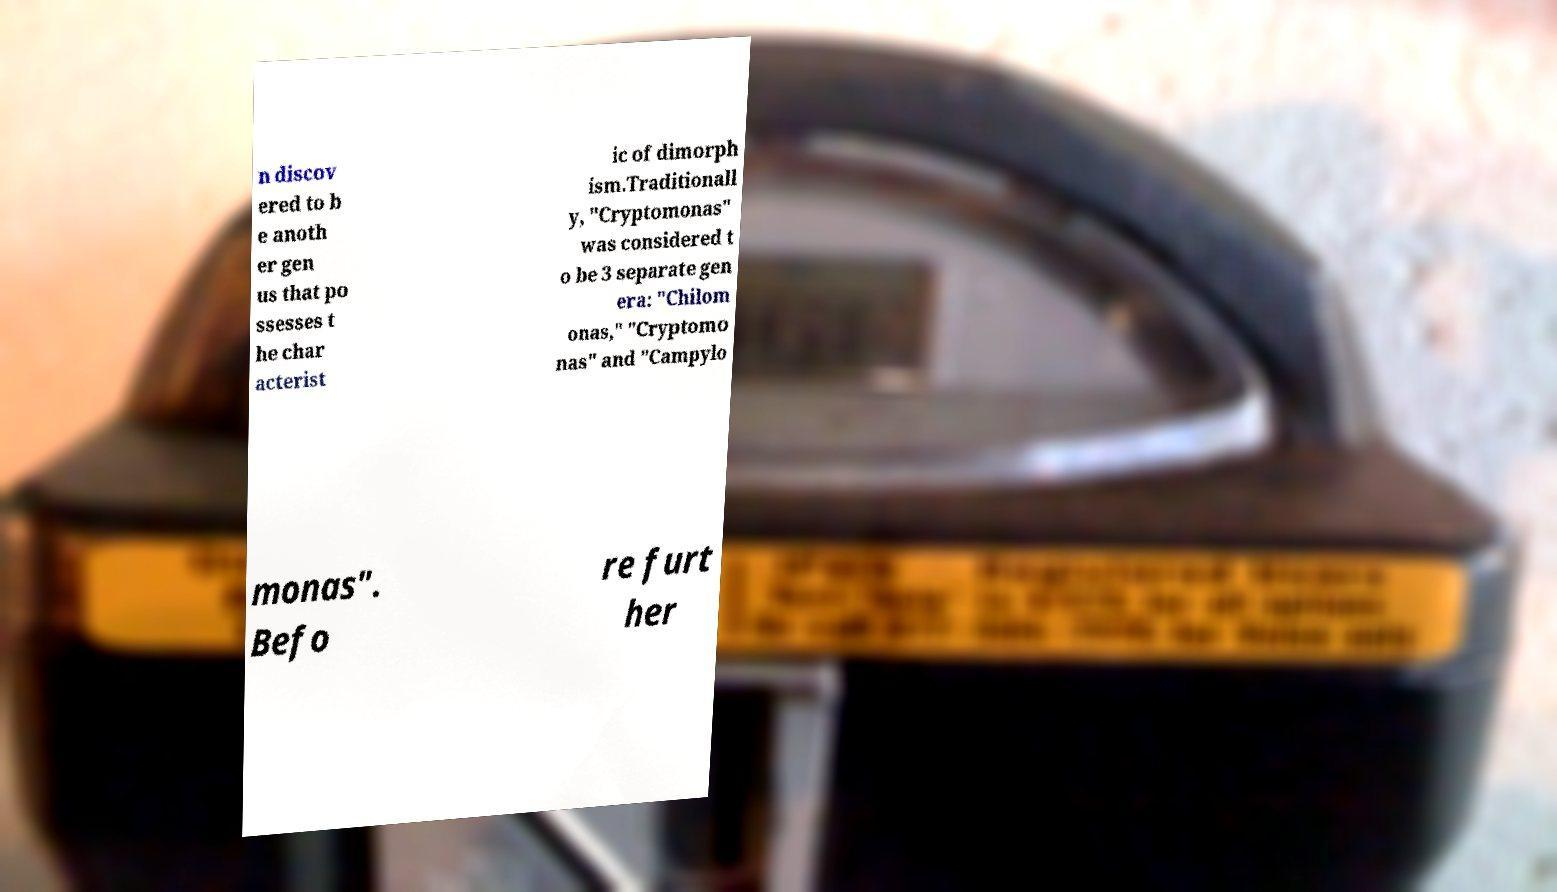Could you assist in decoding the text presented in this image and type it out clearly? n discov ered to b e anoth er gen us that po ssesses t he char acterist ic of dimorph ism.Traditionall y, "Cryptomonas" was considered t o be 3 separate gen era: "Chilom onas," "Cryptomo nas" and "Campylo monas". Befo re furt her 